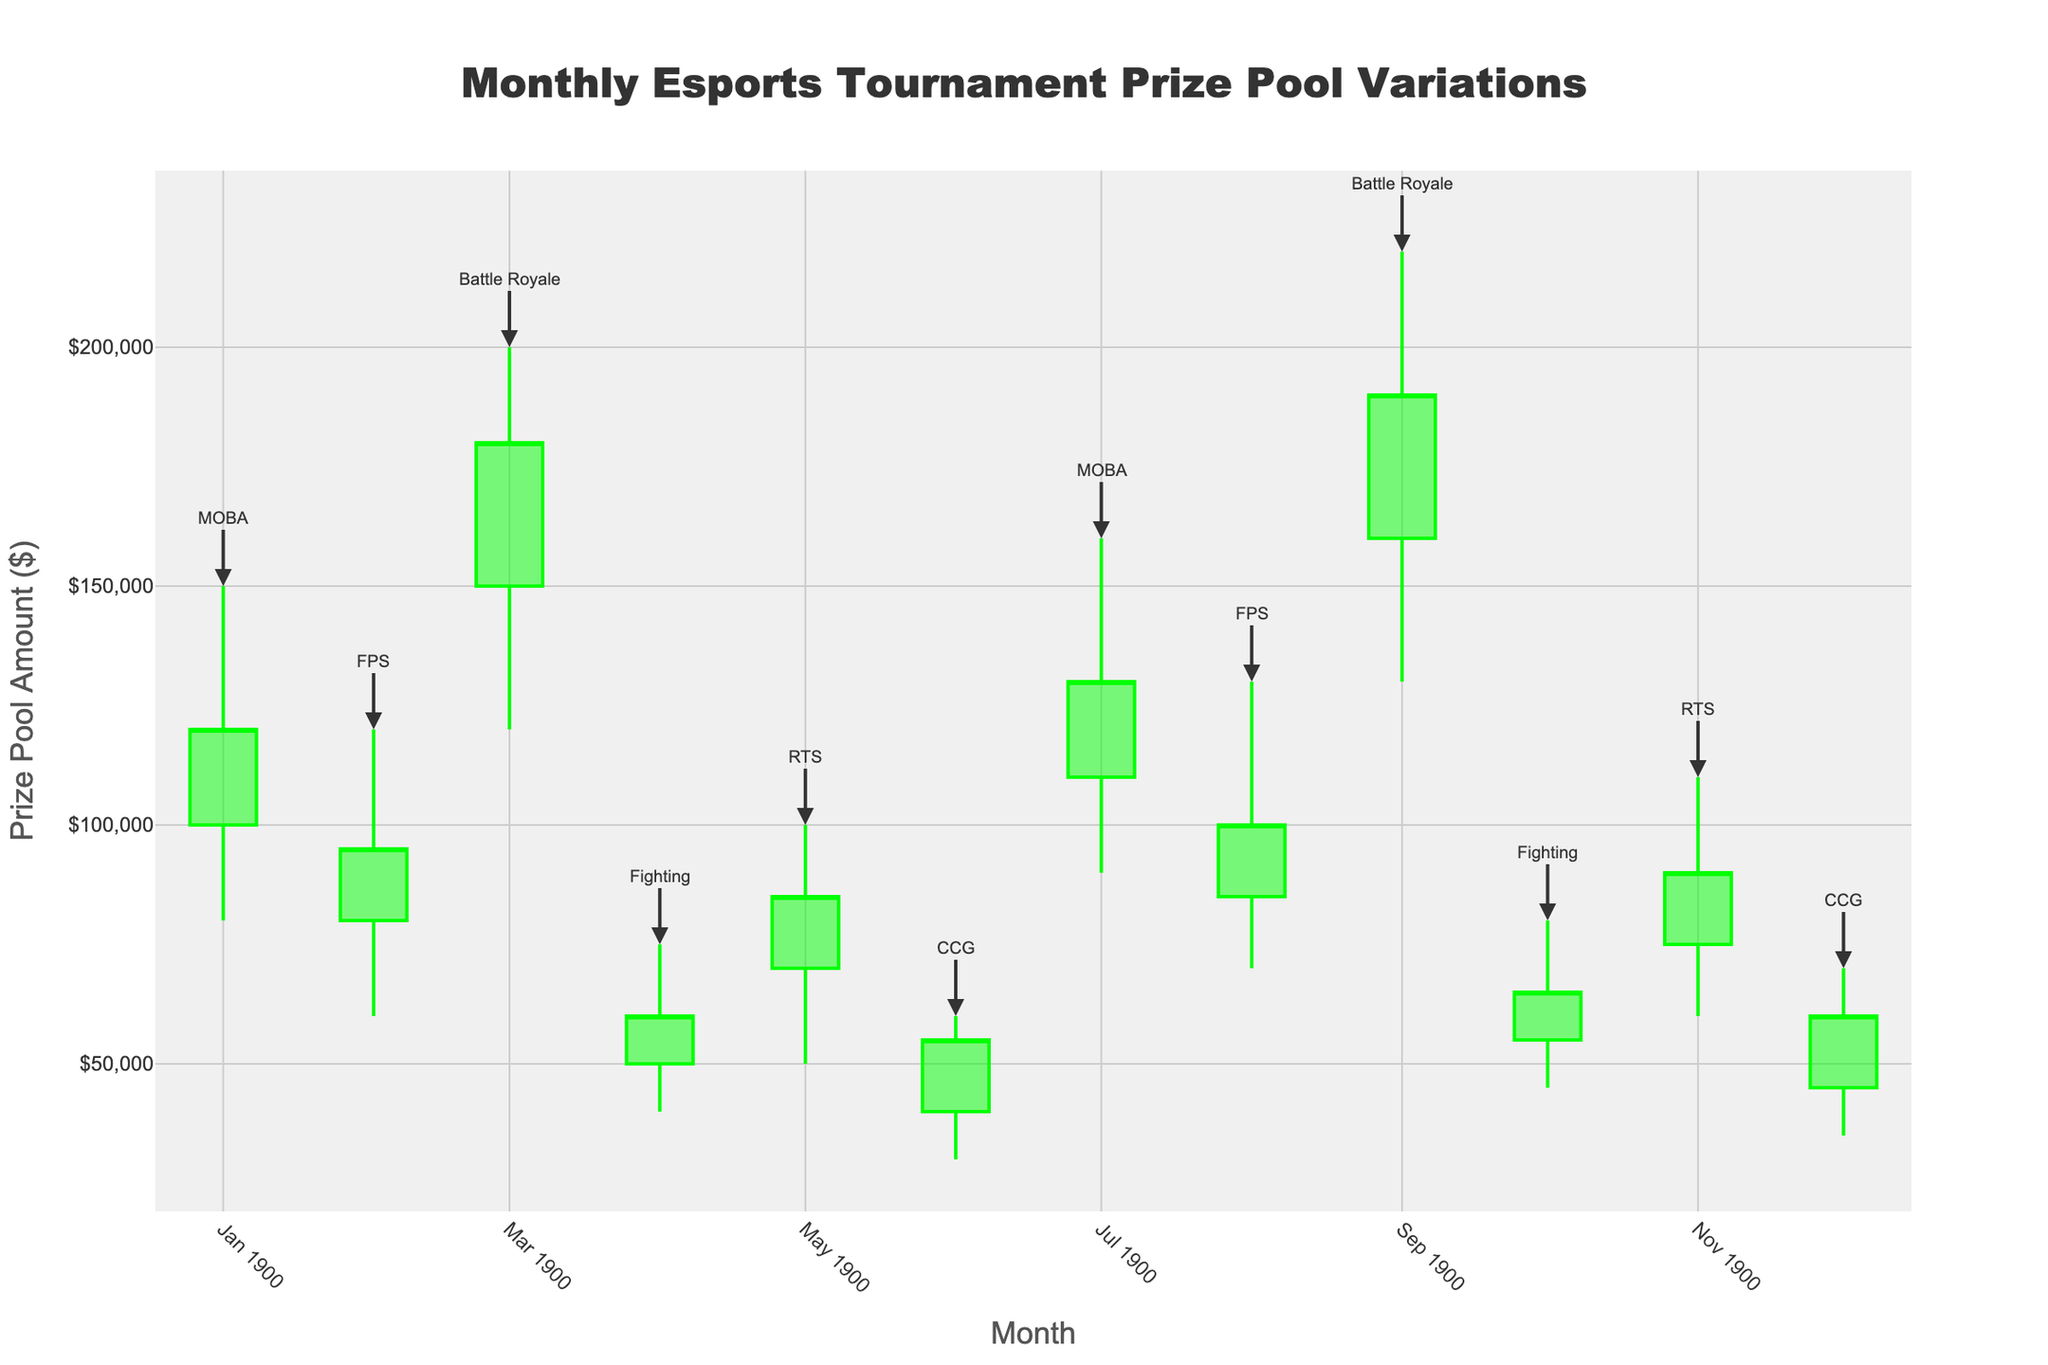What is the title of the chart? The title is prominently displayed at the top of the chart.
Answer: Monthly Esports Tournament Prize Pool Variations What is the highest prize pool recorded for the Battle Royale genre? Find the 'Battle Royale' data points and identify the highest value in the 'High' column.
Answer: $220,000 Which genre had the lowest closing prize pool amount and in which month? Look for the minimum value in the 'Close' column and note both the genre and the corresponding month.
Answer: CCG, June What is the average opening prize pool for the MOBA genre? Identify the opening amounts for MOBA in January and July, then compute the average: (100,000 + 110,000) / 2 = 105,000.
Answer: $105,000 How does the closing prize pool for FPS games change from February to August? Note the closing amounts for FPS in February and August and calculate the difference: 100,000 - 95,000 = 5,000.
Answer: Increased by $5,000 Which month saw the greatest range (difference between high and low values) for prize pools? Calculate the range for each month and identify the maximum value.
Answer: September (Battle Royale) What is the overall trend in the prize pool for the RTS genre from May to November? Examine RTS data in May and November and compare opening, closing, high, and low values.
Answer: Increasing trend Which genre had its maximum prize pool closest to its opening amount? Calculate the difference between high and open for each genre and identify the smallest difference.
Answer: CCG How do the prize pool variations for FPS compare between February and August in terms of high and low values? Compare the high and low values for FPS in the two months. February: high=120,000, low=60,000; August: high=130,000, low=70,000.
Answer: Higher and more stable in August Which genre experienced a higher closing prize pool amount than its opening amount in both instances provided? Locate genres with repeating data points and compare the closing and opening figures. MOBA: Close>Open in both January (120,000 > 100,000) and July (130,000 > 110,000).
Answer: MOBA 